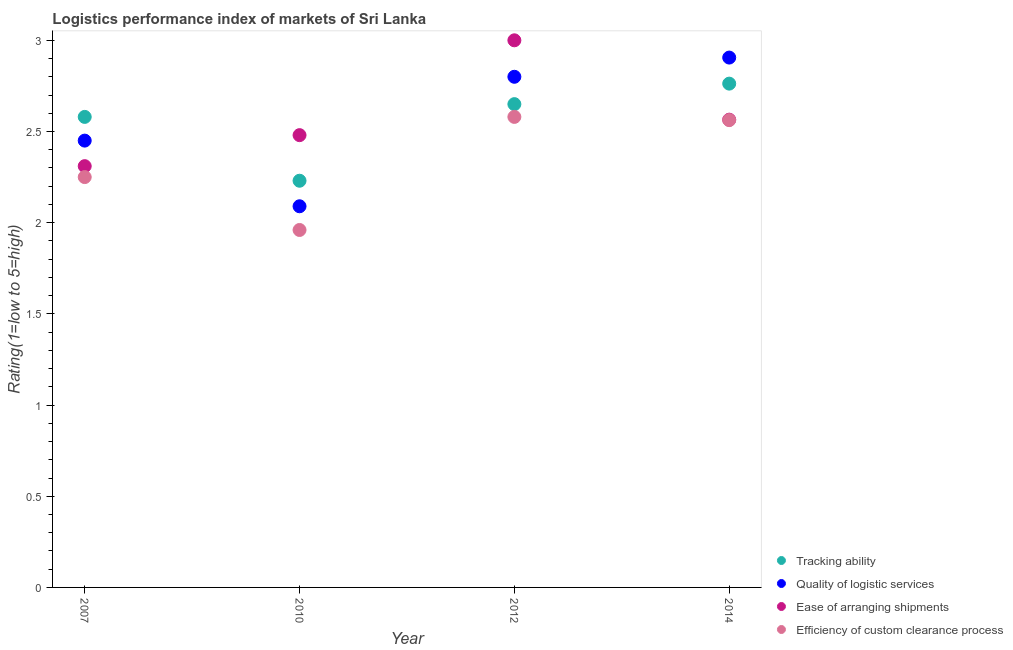How many different coloured dotlines are there?
Provide a succinct answer. 4. What is the lpi rating of efficiency of custom clearance process in 2010?
Offer a terse response. 1.96. Across all years, what is the maximum lpi rating of quality of logistic services?
Your response must be concise. 2.91. Across all years, what is the minimum lpi rating of quality of logistic services?
Make the answer very short. 2.09. In which year was the lpi rating of tracking ability minimum?
Ensure brevity in your answer.  2010. What is the total lpi rating of efficiency of custom clearance process in the graph?
Ensure brevity in your answer.  9.35. What is the difference between the lpi rating of quality of logistic services in 2010 and that in 2014?
Your answer should be very brief. -0.82. What is the difference between the lpi rating of efficiency of custom clearance process in 2010 and the lpi rating of quality of logistic services in 2012?
Make the answer very short. -0.84. What is the average lpi rating of efficiency of custom clearance process per year?
Your response must be concise. 2.34. In the year 2012, what is the difference between the lpi rating of quality of logistic services and lpi rating of efficiency of custom clearance process?
Keep it short and to the point. 0.22. What is the ratio of the lpi rating of efficiency of custom clearance process in 2007 to that in 2014?
Make the answer very short. 0.88. Is the difference between the lpi rating of ease of arranging shipments in 2007 and 2010 greater than the difference between the lpi rating of quality of logistic services in 2007 and 2010?
Give a very brief answer. No. What is the difference between the highest and the second highest lpi rating of ease of arranging shipments?
Offer a very short reply. 0.44. What is the difference between the highest and the lowest lpi rating of ease of arranging shipments?
Give a very brief answer. 0.69. In how many years, is the lpi rating of tracking ability greater than the average lpi rating of tracking ability taken over all years?
Ensure brevity in your answer.  3. Is the sum of the lpi rating of tracking ability in 2007 and 2010 greater than the maximum lpi rating of quality of logistic services across all years?
Offer a terse response. Yes. Is it the case that in every year, the sum of the lpi rating of efficiency of custom clearance process and lpi rating of ease of arranging shipments is greater than the sum of lpi rating of quality of logistic services and lpi rating of tracking ability?
Give a very brief answer. No. Is the lpi rating of tracking ability strictly less than the lpi rating of ease of arranging shipments over the years?
Give a very brief answer. No. What is the difference between two consecutive major ticks on the Y-axis?
Ensure brevity in your answer.  0.5. How many legend labels are there?
Provide a succinct answer. 4. How are the legend labels stacked?
Offer a terse response. Vertical. What is the title of the graph?
Provide a short and direct response. Logistics performance index of markets of Sri Lanka. What is the label or title of the X-axis?
Your answer should be compact. Year. What is the label or title of the Y-axis?
Keep it short and to the point. Rating(1=low to 5=high). What is the Rating(1=low to 5=high) of Tracking ability in 2007?
Give a very brief answer. 2.58. What is the Rating(1=low to 5=high) of Quality of logistic services in 2007?
Give a very brief answer. 2.45. What is the Rating(1=low to 5=high) of Ease of arranging shipments in 2007?
Ensure brevity in your answer.  2.31. What is the Rating(1=low to 5=high) in Efficiency of custom clearance process in 2007?
Provide a short and direct response. 2.25. What is the Rating(1=low to 5=high) of Tracking ability in 2010?
Ensure brevity in your answer.  2.23. What is the Rating(1=low to 5=high) of Quality of logistic services in 2010?
Ensure brevity in your answer.  2.09. What is the Rating(1=low to 5=high) in Ease of arranging shipments in 2010?
Your response must be concise. 2.48. What is the Rating(1=low to 5=high) in Efficiency of custom clearance process in 2010?
Provide a short and direct response. 1.96. What is the Rating(1=low to 5=high) in Tracking ability in 2012?
Keep it short and to the point. 2.65. What is the Rating(1=low to 5=high) in Quality of logistic services in 2012?
Provide a short and direct response. 2.8. What is the Rating(1=low to 5=high) in Efficiency of custom clearance process in 2012?
Make the answer very short. 2.58. What is the Rating(1=low to 5=high) of Tracking ability in 2014?
Keep it short and to the point. 2.76. What is the Rating(1=low to 5=high) of Quality of logistic services in 2014?
Offer a very short reply. 2.91. What is the Rating(1=low to 5=high) in Ease of arranging shipments in 2014?
Make the answer very short. 2.56. What is the Rating(1=low to 5=high) of Efficiency of custom clearance process in 2014?
Your response must be concise. 2.56. Across all years, what is the maximum Rating(1=low to 5=high) of Tracking ability?
Give a very brief answer. 2.76. Across all years, what is the maximum Rating(1=low to 5=high) in Quality of logistic services?
Ensure brevity in your answer.  2.91. Across all years, what is the maximum Rating(1=low to 5=high) in Efficiency of custom clearance process?
Offer a terse response. 2.58. Across all years, what is the minimum Rating(1=low to 5=high) of Tracking ability?
Offer a terse response. 2.23. Across all years, what is the minimum Rating(1=low to 5=high) of Quality of logistic services?
Your response must be concise. 2.09. Across all years, what is the minimum Rating(1=low to 5=high) in Ease of arranging shipments?
Your answer should be very brief. 2.31. Across all years, what is the minimum Rating(1=low to 5=high) of Efficiency of custom clearance process?
Your answer should be very brief. 1.96. What is the total Rating(1=low to 5=high) in Tracking ability in the graph?
Your response must be concise. 10.22. What is the total Rating(1=low to 5=high) in Quality of logistic services in the graph?
Offer a terse response. 10.25. What is the total Rating(1=low to 5=high) of Ease of arranging shipments in the graph?
Offer a very short reply. 10.35. What is the total Rating(1=low to 5=high) in Efficiency of custom clearance process in the graph?
Your response must be concise. 9.35. What is the difference between the Rating(1=low to 5=high) in Tracking ability in 2007 and that in 2010?
Provide a short and direct response. 0.35. What is the difference between the Rating(1=low to 5=high) in Quality of logistic services in 2007 and that in 2010?
Provide a short and direct response. 0.36. What is the difference between the Rating(1=low to 5=high) in Ease of arranging shipments in 2007 and that in 2010?
Provide a short and direct response. -0.17. What is the difference between the Rating(1=low to 5=high) in Efficiency of custom clearance process in 2007 and that in 2010?
Offer a terse response. 0.29. What is the difference between the Rating(1=low to 5=high) in Tracking ability in 2007 and that in 2012?
Provide a succinct answer. -0.07. What is the difference between the Rating(1=low to 5=high) in Quality of logistic services in 2007 and that in 2012?
Provide a succinct answer. -0.35. What is the difference between the Rating(1=low to 5=high) of Ease of arranging shipments in 2007 and that in 2012?
Provide a succinct answer. -0.69. What is the difference between the Rating(1=low to 5=high) of Efficiency of custom clearance process in 2007 and that in 2012?
Give a very brief answer. -0.33. What is the difference between the Rating(1=low to 5=high) in Tracking ability in 2007 and that in 2014?
Provide a short and direct response. -0.18. What is the difference between the Rating(1=low to 5=high) of Quality of logistic services in 2007 and that in 2014?
Make the answer very short. -0.46. What is the difference between the Rating(1=low to 5=high) in Ease of arranging shipments in 2007 and that in 2014?
Your answer should be very brief. -0.25. What is the difference between the Rating(1=low to 5=high) of Efficiency of custom clearance process in 2007 and that in 2014?
Provide a short and direct response. -0.31. What is the difference between the Rating(1=low to 5=high) of Tracking ability in 2010 and that in 2012?
Ensure brevity in your answer.  -0.42. What is the difference between the Rating(1=low to 5=high) in Quality of logistic services in 2010 and that in 2012?
Give a very brief answer. -0.71. What is the difference between the Rating(1=low to 5=high) in Ease of arranging shipments in 2010 and that in 2012?
Give a very brief answer. -0.52. What is the difference between the Rating(1=low to 5=high) of Efficiency of custom clearance process in 2010 and that in 2012?
Offer a terse response. -0.62. What is the difference between the Rating(1=low to 5=high) of Tracking ability in 2010 and that in 2014?
Offer a very short reply. -0.53. What is the difference between the Rating(1=low to 5=high) of Quality of logistic services in 2010 and that in 2014?
Keep it short and to the point. -0.82. What is the difference between the Rating(1=low to 5=high) of Ease of arranging shipments in 2010 and that in 2014?
Your response must be concise. -0.08. What is the difference between the Rating(1=low to 5=high) in Efficiency of custom clearance process in 2010 and that in 2014?
Provide a succinct answer. -0.6. What is the difference between the Rating(1=low to 5=high) in Tracking ability in 2012 and that in 2014?
Your response must be concise. -0.11. What is the difference between the Rating(1=low to 5=high) in Quality of logistic services in 2012 and that in 2014?
Offer a very short reply. -0.11. What is the difference between the Rating(1=low to 5=high) in Ease of arranging shipments in 2012 and that in 2014?
Provide a short and direct response. 0.44. What is the difference between the Rating(1=low to 5=high) in Efficiency of custom clearance process in 2012 and that in 2014?
Provide a short and direct response. 0.02. What is the difference between the Rating(1=low to 5=high) in Tracking ability in 2007 and the Rating(1=low to 5=high) in Quality of logistic services in 2010?
Your response must be concise. 0.49. What is the difference between the Rating(1=low to 5=high) in Tracking ability in 2007 and the Rating(1=low to 5=high) in Efficiency of custom clearance process in 2010?
Your answer should be compact. 0.62. What is the difference between the Rating(1=low to 5=high) of Quality of logistic services in 2007 and the Rating(1=low to 5=high) of Ease of arranging shipments in 2010?
Ensure brevity in your answer.  -0.03. What is the difference between the Rating(1=low to 5=high) of Quality of logistic services in 2007 and the Rating(1=low to 5=high) of Efficiency of custom clearance process in 2010?
Your answer should be very brief. 0.49. What is the difference between the Rating(1=low to 5=high) in Ease of arranging shipments in 2007 and the Rating(1=low to 5=high) in Efficiency of custom clearance process in 2010?
Your answer should be very brief. 0.35. What is the difference between the Rating(1=low to 5=high) of Tracking ability in 2007 and the Rating(1=low to 5=high) of Quality of logistic services in 2012?
Offer a very short reply. -0.22. What is the difference between the Rating(1=low to 5=high) in Tracking ability in 2007 and the Rating(1=low to 5=high) in Ease of arranging shipments in 2012?
Provide a succinct answer. -0.42. What is the difference between the Rating(1=low to 5=high) in Tracking ability in 2007 and the Rating(1=low to 5=high) in Efficiency of custom clearance process in 2012?
Give a very brief answer. 0. What is the difference between the Rating(1=low to 5=high) in Quality of logistic services in 2007 and the Rating(1=low to 5=high) in Ease of arranging shipments in 2012?
Your answer should be very brief. -0.55. What is the difference between the Rating(1=low to 5=high) in Quality of logistic services in 2007 and the Rating(1=low to 5=high) in Efficiency of custom clearance process in 2012?
Your answer should be very brief. -0.13. What is the difference between the Rating(1=low to 5=high) in Ease of arranging shipments in 2007 and the Rating(1=low to 5=high) in Efficiency of custom clearance process in 2012?
Offer a terse response. -0.27. What is the difference between the Rating(1=low to 5=high) in Tracking ability in 2007 and the Rating(1=low to 5=high) in Quality of logistic services in 2014?
Make the answer very short. -0.33. What is the difference between the Rating(1=low to 5=high) of Tracking ability in 2007 and the Rating(1=low to 5=high) of Ease of arranging shipments in 2014?
Provide a short and direct response. 0.02. What is the difference between the Rating(1=low to 5=high) of Tracking ability in 2007 and the Rating(1=low to 5=high) of Efficiency of custom clearance process in 2014?
Keep it short and to the point. 0.02. What is the difference between the Rating(1=low to 5=high) in Quality of logistic services in 2007 and the Rating(1=low to 5=high) in Ease of arranging shipments in 2014?
Keep it short and to the point. -0.11. What is the difference between the Rating(1=low to 5=high) of Quality of logistic services in 2007 and the Rating(1=low to 5=high) of Efficiency of custom clearance process in 2014?
Keep it short and to the point. -0.11. What is the difference between the Rating(1=low to 5=high) of Ease of arranging shipments in 2007 and the Rating(1=low to 5=high) of Efficiency of custom clearance process in 2014?
Your answer should be very brief. -0.25. What is the difference between the Rating(1=low to 5=high) in Tracking ability in 2010 and the Rating(1=low to 5=high) in Quality of logistic services in 2012?
Give a very brief answer. -0.57. What is the difference between the Rating(1=low to 5=high) of Tracking ability in 2010 and the Rating(1=low to 5=high) of Ease of arranging shipments in 2012?
Your response must be concise. -0.77. What is the difference between the Rating(1=low to 5=high) of Tracking ability in 2010 and the Rating(1=low to 5=high) of Efficiency of custom clearance process in 2012?
Make the answer very short. -0.35. What is the difference between the Rating(1=low to 5=high) in Quality of logistic services in 2010 and the Rating(1=low to 5=high) in Ease of arranging shipments in 2012?
Your answer should be very brief. -0.91. What is the difference between the Rating(1=low to 5=high) of Quality of logistic services in 2010 and the Rating(1=low to 5=high) of Efficiency of custom clearance process in 2012?
Offer a terse response. -0.49. What is the difference between the Rating(1=low to 5=high) in Tracking ability in 2010 and the Rating(1=low to 5=high) in Quality of logistic services in 2014?
Ensure brevity in your answer.  -0.68. What is the difference between the Rating(1=low to 5=high) of Tracking ability in 2010 and the Rating(1=low to 5=high) of Ease of arranging shipments in 2014?
Keep it short and to the point. -0.33. What is the difference between the Rating(1=low to 5=high) in Tracking ability in 2010 and the Rating(1=low to 5=high) in Efficiency of custom clearance process in 2014?
Provide a succinct answer. -0.33. What is the difference between the Rating(1=low to 5=high) of Quality of logistic services in 2010 and the Rating(1=low to 5=high) of Ease of arranging shipments in 2014?
Your answer should be compact. -0.47. What is the difference between the Rating(1=low to 5=high) in Quality of logistic services in 2010 and the Rating(1=low to 5=high) in Efficiency of custom clearance process in 2014?
Offer a terse response. -0.47. What is the difference between the Rating(1=low to 5=high) of Ease of arranging shipments in 2010 and the Rating(1=low to 5=high) of Efficiency of custom clearance process in 2014?
Offer a terse response. -0.08. What is the difference between the Rating(1=low to 5=high) of Tracking ability in 2012 and the Rating(1=low to 5=high) of Quality of logistic services in 2014?
Make the answer very short. -0.26. What is the difference between the Rating(1=low to 5=high) of Tracking ability in 2012 and the Rating(1=low to 5=high) of Ease of arranging shipments in 2014?
Your answer should be compact. 0.09. What is the difference between the Rating(1=low to 5=high) of Tracking ability in 2012 and the Rating(1=low to 5=high) of Efficiency of custom clearance process in 2014?
Keep it short and to the point. 0.09. What is the difference between the Rating(1=low to 5=high) in Quality of logistic services in 2012 and the Rating(1=low to 5=high) in Ease of arranging shipments in 2014?
Your answer should be compact. 0.24. What is the difference between the Rating(1=low to 5=high) of Quality of logistic services in 2012 and the Rating(1=low to 5=high) of Efficiency of custom clearance process in 2014?
Provide a short and direct response. 0.24. What is the difference between the Rating(1=low to 5=high) of Ease of arranging shipments in 2012 and the Rating(1=low to 5=high) of Efficiency of custom clearance process in 2014?
Provide a short and direct response. 0.44. What is the average Rating(1=low to 5=high) of Tracking ability per year?
Your response must be concise. 2.56. What is the average Rating(1=low to 5=high) in Quality of logistic services per year?
Provide a short and direct response. 2.56. What is the average Rating(1=low to 5=high) of Ease of arranging shipments per year?
Provide a short and direct response. 2.59. What is the average Rating(1=low to 5=high) in Efficiency of custom clearance process per year?
Make the answer very short. 2.34. In the year 2007, what is the difference between the Rating(1=low to 5=high) of Tracking ability and Rating(1=low to 5=high) of Quality of logistic services?
Keep it short and to the point. 0.13. In the year 2007, what is the difference between the Rating(1=low to 5=high) of Tracking ability and Rating(1=low to 5=high) of Ease of arranging shipments?
Keep it short and to the point. 0.27. In the year 2007, what is the difference between the Rating(1=low to 5=high) of Tracking ability and Rating(1=low to 5=high) of Efficiency of custom clearance process?
Give a very brief answer. 0.33. In the year 2007, what is the difference between the Rating(1=low to 5=high) of Quality of logistic services and Rating(1=low to 5=high) of Ease of arranging shipments?
Make the answer very short. 0.14. In the year 2007, what is the difference between the Rating(1=low to 5=high) in Quality of logistic services and Rating(1=low to 5=high) in Efficiency of custom clearance process?
Ensure brevity in your answer.  0.2. In the year 2010, what is the difference between the Rating(1=low to 5=high) of Tracking ability and Rating(1=low to 5=high) of Quality of logistic services?
Give a very brief answer. 0.14. In the year 2010, what is the difference between the Rating(1=low to 5=high) of Tracking ability and Rating(1=low to 5=high) of Ease of arranging shipments?
Ensure brevity in your answer.  -0.25. In the year 2010, what is the difference between the Rating(1=low to 5=high) of Tracking ability and Rating(1=low to 5=high) of Efficiency of custom clearance process?
Offer a terse response. 0.27. In the year 2010, what is the difference between the Rating(1=low to 5=high) in Quality of logistic services and Rating(1=low to 5=high) in Ease of arranging shipments?
Give a very brief answer. -0.39. In the year 2010, what is the difference between the Rating(1=low to 5=high) of Quality of logistic services and Rating(1=low to 5=high) of Efficiency of custom clearance process?
Keep it short and to the point. 0.13. In the year 2010, what is the difference between the Rating(1=low to 5=high) of Ease of arranging shipments and Rating(1=low to 5=high) of Efficiency of custom clearance process?
Provide a succinct answer. 0.52. In the year 2012, what is the difference between the Rating(1=low to 5=high) of Tracking ability and Rating(1=low to 5=high) of Quality of logistic services?
Make the answer very short. -0.15. In the year 2012, what is the difference between the Rating(1=low to 5=high) in Tracking ability and Rating(1=low to 5=high) in Ease of arranging shipments?
Keep it short and to the point. -0.35. In the year 2012, what is the difference between the Rating(1=low to 5=high) in Tracking ability and Rating(1=low to 5=high) in Efficiency of custom clearance process?
Make the answer very short. 0.07. In the year 2012, what is the difference between the Rating(1=low to 5=high) of Quality of logistic services and Rating(1=low to 5=high) of Ease of arranging shipments?
Make the answer very short. -0.2. In the year 2012, what is the difference between the Rating(1=low to 5=high) in Quality of logistic services and Rating(1=low to 5=high) in Efficiency of custom clearance process?
Your response must be concise. 0.22. In the year 2012, what is the difference between the Rating(1=low to 5=high) in Ease of arranging shipments and Rating(1=low to 5=high) in Efficiency of custom clearance process?
Your answer should be compact. 0.42. In the year 2014, what is the difference between the Rating(1=low to 5=high) in Tracking ability and Rating(1=low to 5=high) in Quality of logistic services?
Keep it short and to the point. -0.14. In the year 2014, what is the difference between the Rating(1=low to 5=high) of Tracking ability and Rating(1=low to 5=high) of Ease of arranging shipments?
Keep it short and to the point. 0.2. In the year 2014, what is the difference between the Rating(1=low to 5=high) in Tracking ability and Rating(1=low to 5=high) in Efficiency of custom clearance process?
Provide a short and direct response. 0.2. In the year 2014, what is the difference between the Rating(1=low to 5=high) in Quality of logistic services and Rating(1=low to 5=high) in Ease of arranging shipments?
Keep it short and to the point. 0.34. In the year 2014, what is the difference between the Rating(1=low to 5=high) in Quality of logistic services and Rating(1=low to 5=high) in Efficiency of custom clearance process?
Your response must be concise. 0.34. In the year 2014, what is the difference between the Rating(1=low to 5=high) in Ease of arranging shipments and Rating(1=low to 5=high) in Efficiency of custom clearance process?
Your response must be concise. 0. What is the ratio of the Rating(1=low to 5=high) in Tracking ability in 2007 to that in 2010?
Your answer should be compact. 1.16. What is the ratio of the Rating(1=low to 5=high) of Quality of logistic services in 2007 to that in 2010?
Make the answer very short. 1.17. What is the ratio of the Rating(1=low to 5=high) of Ease of arranging shipments in 2007 to that in 2010?
Your answer should be very brief. 0.93. What is the ratio of the Rating(1=low to 5=high) in Efficiency of custom clearance process in 2007 to that in 2010?
Give a very brief answer. 1.15. What is the ratio of the Rating(1=low to 5=high) of Tracking ability in 2007 to that in 2012?
Give a very brief answer. 0.97. What is the ratio of the Rating(1=low to 5=high) in Quality of logistic services in 2007 to that in 2012?
Provide a short and direct response. 0.88. What is the ratio of the Rating(1=low to 5=high) of Ease of arranging shipments in 2007 to that in 2012?
Your response must be concise. 0.77. What is the ratio of the Rating(1=low to 5=high) in Efficiency of custom clearance process in 2007 to that in 2012?
Provide a succinct answer. 0.87. What is the ratio of the Rating(1=low to 5=high) in Tracking ability in 2007 to that in 2014?
Give a very brief answer. 0.93. What is the ratio of the Rating(1=low to 5=high) of Quality of logistic services in 2007 to that in 2014?
Offer a terse response. 0.84. What is the ratio of the Rating(1=low to 5=high) in Ease of arranging shipments in 2007 to that in 2014?
Offer a very short reply. 0.9. What is the ratio of the Rating(1=low to 5=high) of Efficiency of custom clearance process in 2007 to that in 2014?
Your response must be concise. 0.88. What is the ratio of the Rating(1=low to 5=high) of Tracking ability in 2010 to that in 2012?
Your response must be concise. 0.84. What is the ratio of the Rating(1=low to 5=high) of Quality of logistic services in 2010 to that in 2012?
Your response must be concise. 0.75. What is the ratio of the Rating(1=low to 5=high) of Ease of arranging shipments in 2010 to that in 2012?
Give a very brief answer. 0.83. What is the ratio of the Rating(1=low to 5=high) of Efficiency of custom clearance process in 2010 to that in 2012?
Your response must be concise. 0.76. What is the ratio of the Rating(1=low to 5=high) of Tracking ability in 2010 to that in 2014?
Your answer should be very brief. 0.81. What is the ratio of the Rating(1=low to 5=high) in Quality of logistic services in 2010 to that in 2014?
Provide a short and direct response. 0.72. What is the ratio of the Rating(1=low to 5=high) in Ease of arranging shipments in 2010 to that in 2014?
Keep it short and to the point. 0.97. What is the ratio of the Rating(1=low to 5=high) in Efficiency of custom clearance process in 2010 to that in 2014?
Provide a short and direct response. 0.76. What is the ratio of the Rating(1=low to 5=high) in Tracking ability in 2012 to that in 2014?
Your answer should be compact. 0.96. What is the ratio of the Rating(1=low to 5=high) in Quality of logistic services in 2012 to that in 2014?
Keep it short and to the point. 0.96. What is the ratio of the Rating(1=low to 5=high) in Ease of arranging shipments in 2012 to that in 2014?
Keep it short and to the point. 1.17. What is the ratio of the Rating(1=low to 5=high) in Efficiency of custom clearance process in 2012 to that in 2014?
Your answer should be compact. 1.01. What is the difference between the highest and the second highest Rating(1=low to 5=high) in Tracking ability?
Offer a terse response. 0.11. What is the difference between the highest and the second highest Rating(1=low to 5=high) in Quality of logistic services?
Your answer should be compact. 0.11. What is the difference between the highest and the second highest Rating(1=low to 5=high) in Ease of arranging shipments?
Make the answer very short. 0.44. What is the difference between the highest and the second highest Rating(1=low to 5=high) in Efficiency of custom clearance process?
Your answer should be very brief. 0.02. What is the difference between the highest and the lowest Rating(1=low to 5=high) in Tracking ability?
Offer a terse response. 0.53. What is the difference between the highest and the lowest Rating(1=low to 5=high) in Quality of logistic services?
Offer a very short reply. 0.82. What is the difference between the highest and the lowest Rating(1=low to 5=high) of Ease of arranging shipments?
Offer a very short reply. 0.69. What is the difference between the highest and the lowest Rating(1=low to 5=high) of Efficiency of custom clearance process?
Your answer should be compact. 0.62. 